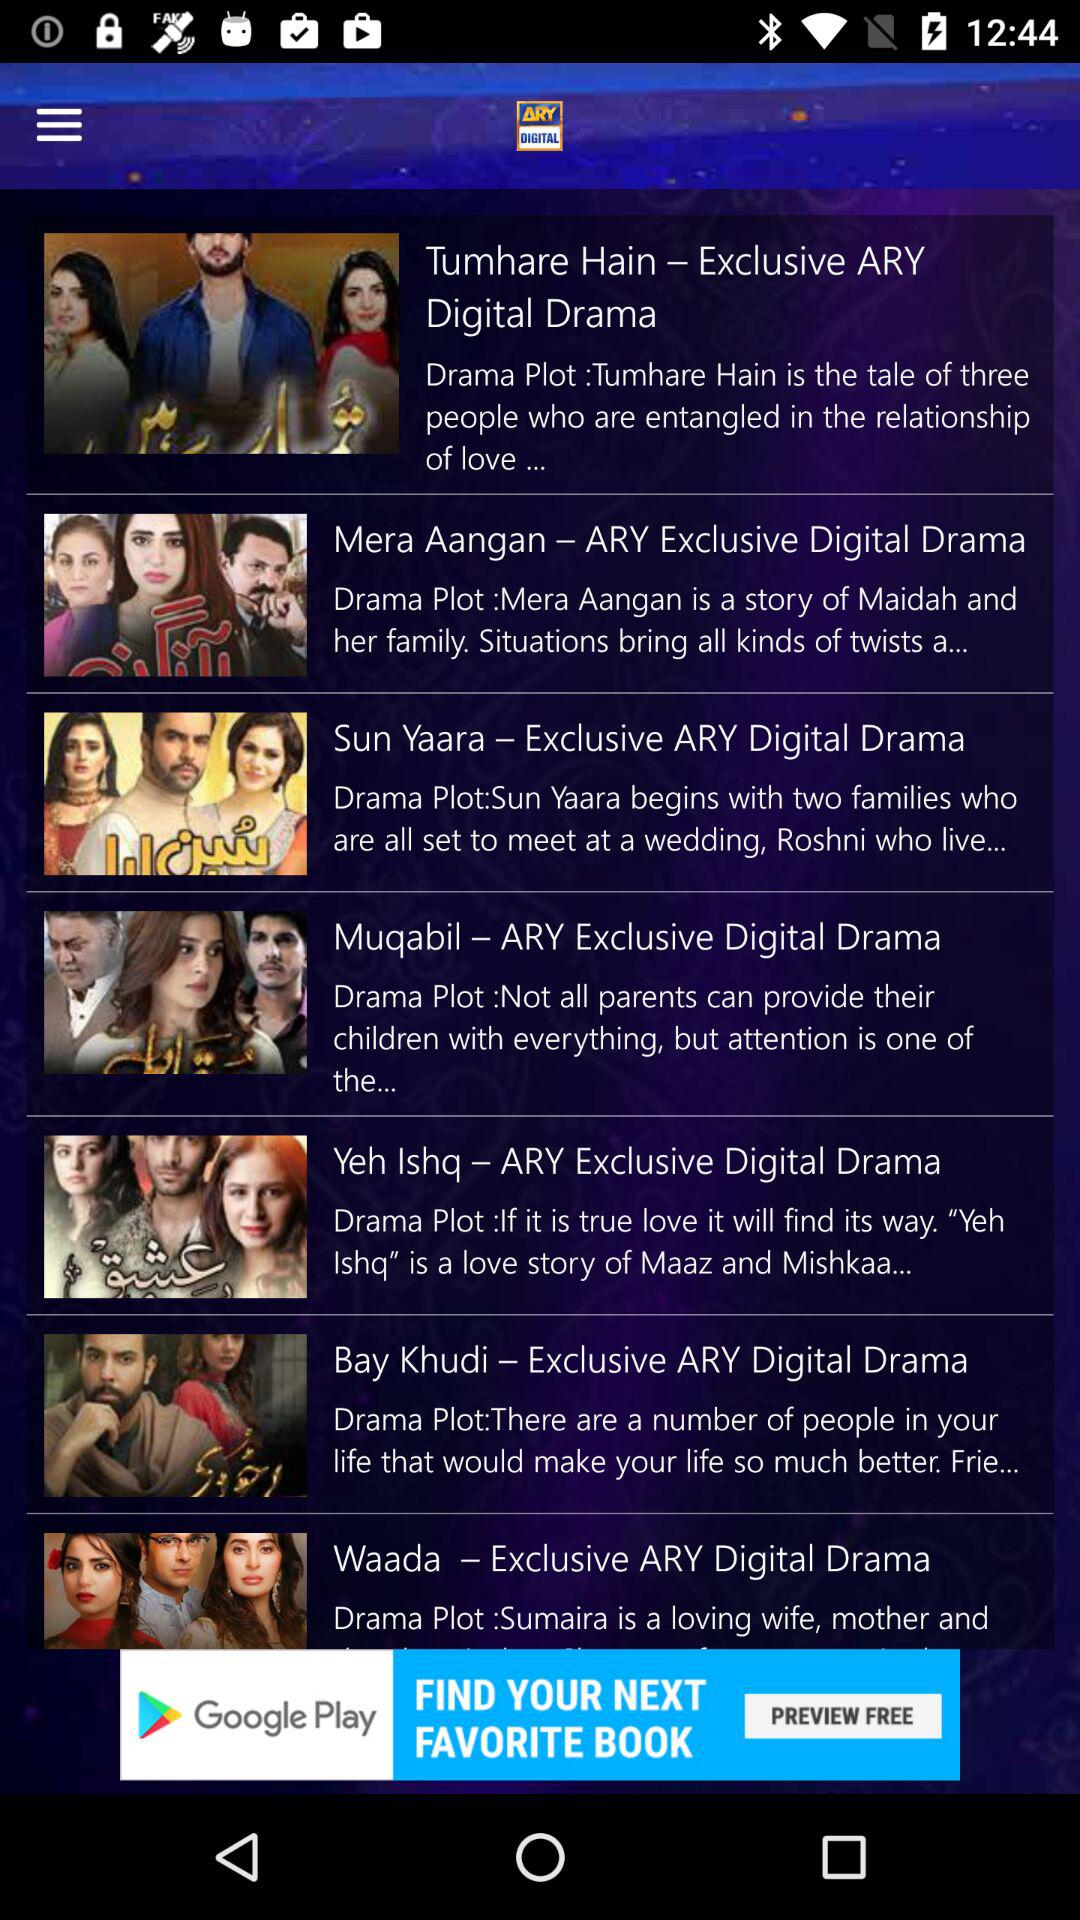What is the name of the drama's? The names of the dramas are "Tumhare Hain", "Mera Aangan", "Sun Yaara", "Muqabil", "Yeh Ishq", "Bay Khudi" and "Waada". 